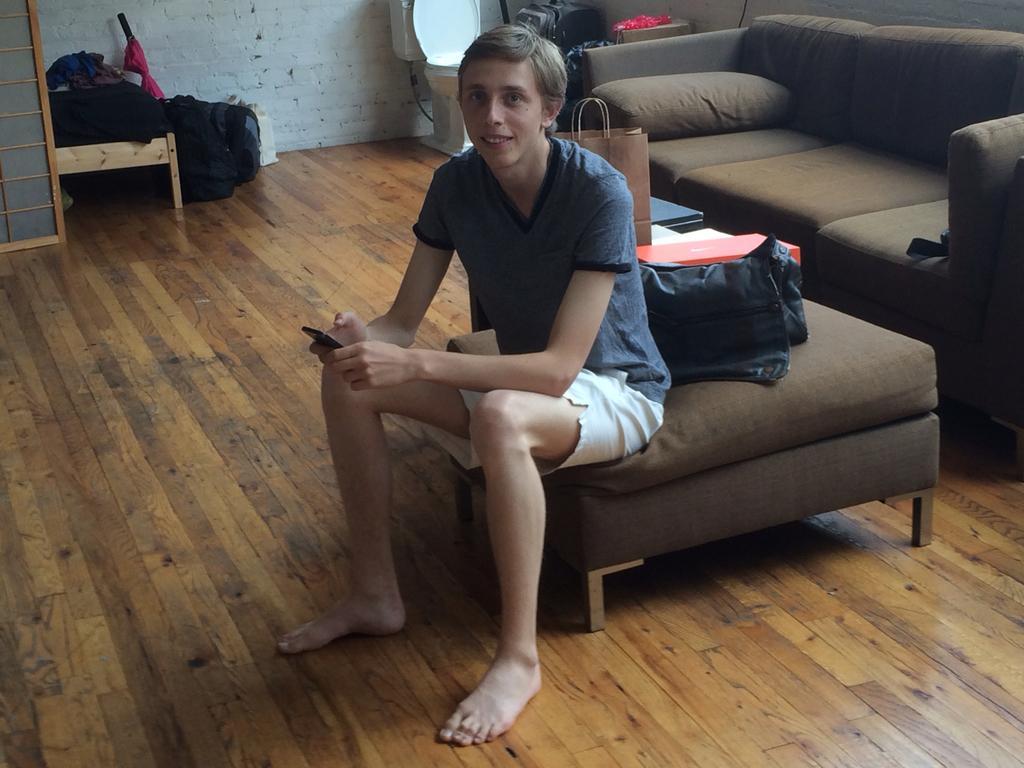Can you describe this image briefly? In the image we can see boy sitting on a sofa table. There is a bag behind him. He is holding an object. 